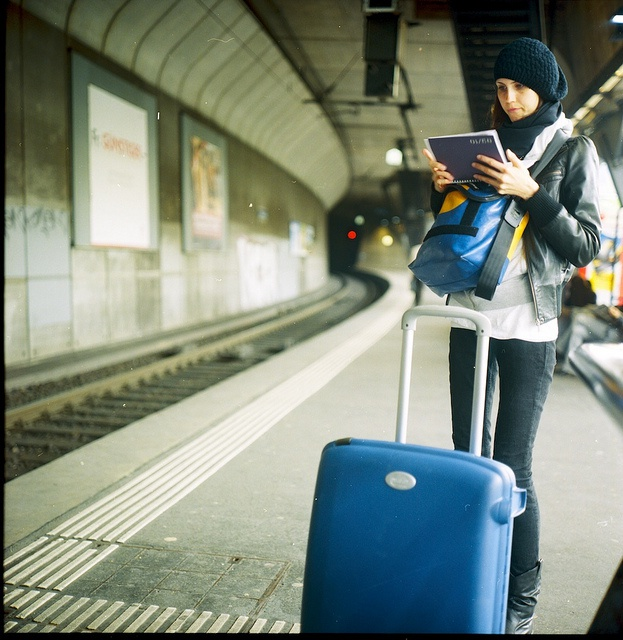Describe the objects in this image and their specific colors. I can see suitcase in black, blue, darkblue, and lightgray tones, people in black, lightgray, gray, and purple tones, and handbag in black, blue, and darkblue tones in this image. 